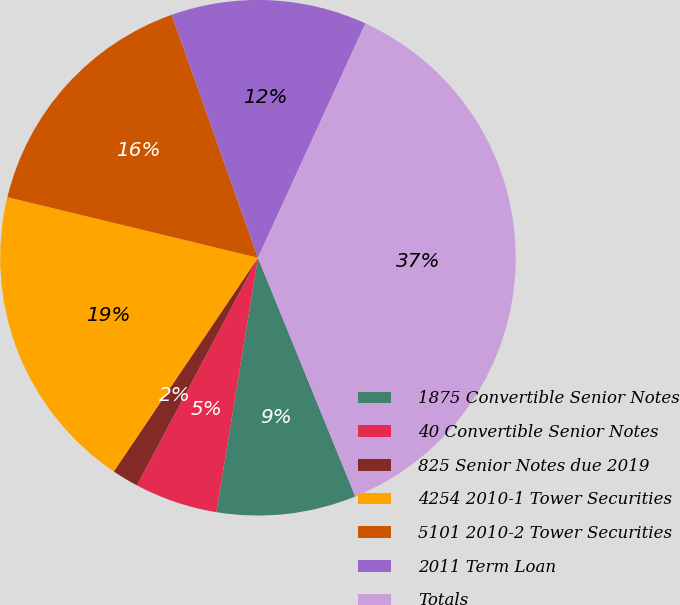Convert chart. <chart><loc_0><loc_0><loc_500><loc_500><pie_chart><fcel>1875 Convertible Senior Notes<fcel>40 Convertible Senior Notes<fcel>825 Senior Notes due 2019<fcel>4254 2010-1 Tower Securities<fcel>5101 2010-2 Tower Securities<fcel>2011 Term Loan<fcel>Totals<nl><fcel>8.74%<fcel>5.2%<fcel>1.67%<fcel>19.33%<fcel>15.8%<fcel>12.27%<fcel>36.99%<nl></chart> 